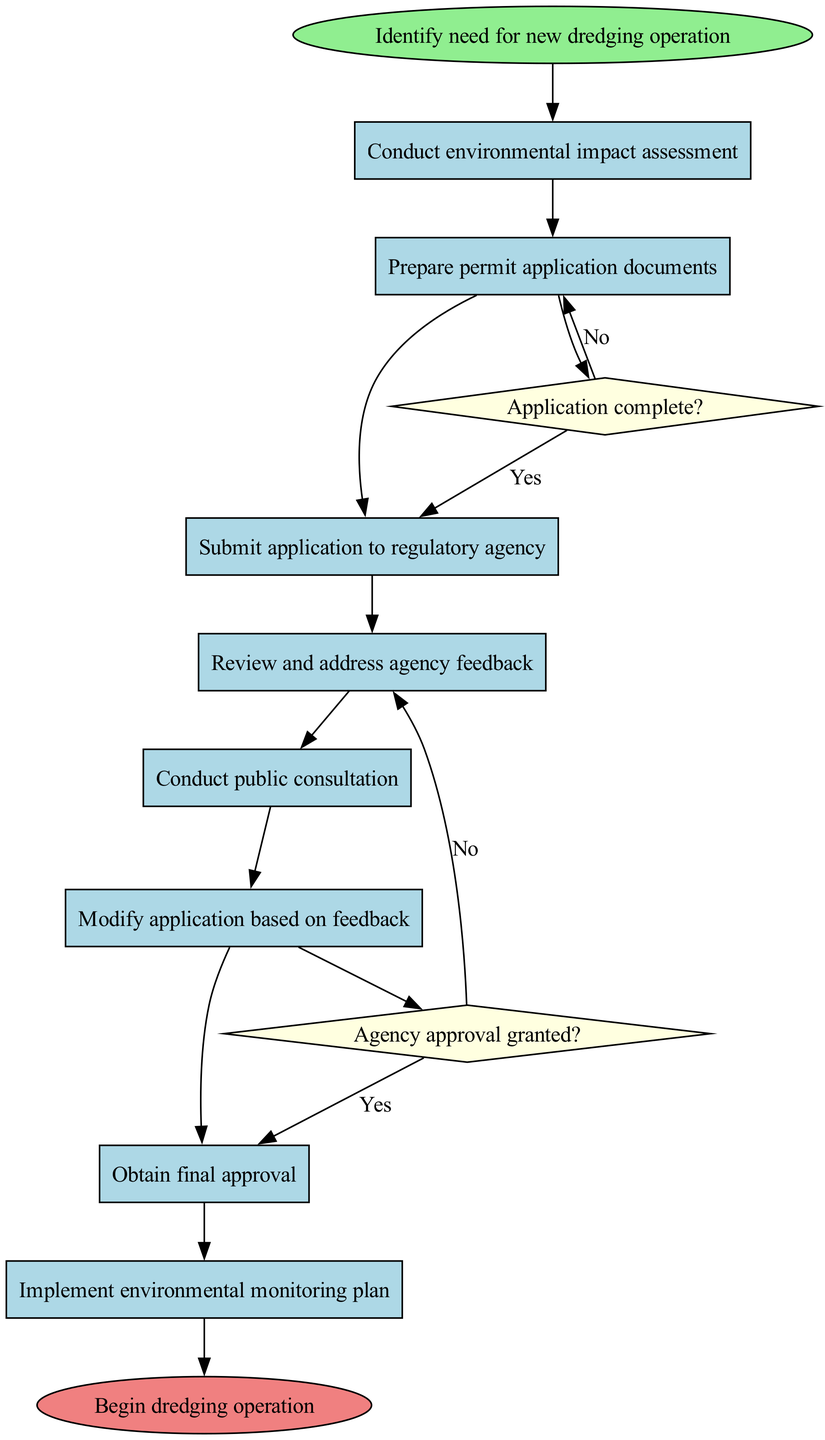What is the start node of the diagram? The start node is named "Identify need for new dredging operation," which is the first action that initiates the process.
Answer: Identify need for new dredging operation How many activities are listed in the diagram? There are eight activities, including both actions and the processes involved in the environmental permit application.
Answer: 8 What is the end node of the diagram? The end node is "Begin dredging operation," indicating the final step of the process after all prior activities have been completed.
Answer: Begin dredging operation What is the second activity in the sequence? The second activity listed is "Prepare permit application documents," which comes immediately after the first activity in the process.
Answer: Prepare permit application documents What happens if the application is not complete? If the application is not complete, the next step is to "Prepare permit application documents," indicating that further work is needed before submission.
Answer: Prepare permit application documents How many decision nodes are present in the diagram? There are two decision nodes in the diagram, which are used to determine the flow of the application process based on specific conditions.
Answer: 2 What is the condition of the first decision node? The first decision node's condition is "Application complete?" which determines whether the application is ready for submission.
Answer: Application complete? What occurs after agency approval is granted? After agency approval is granted, the next step in the process is "Obtain final approval," which signifies the culmination of the approval process.
Answer: Obtain final approval What does the flow diagram indicate should be done after conducting public consultation? After conducting public consultation, the process indicates that one should "Modify application based on feedback," showing the need to incorporate public input.
Answer: Modify application based on feedback 